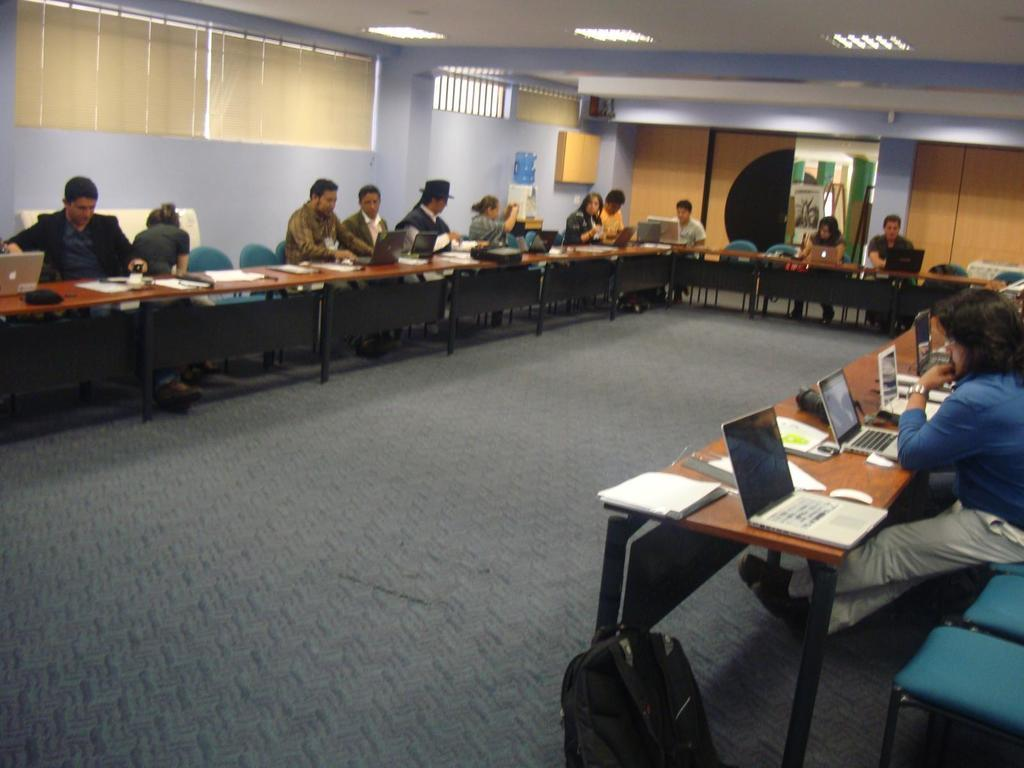How many people are in the image? There is a group of people in the image. What are the people doing in the image? The people are seated on chairs. What objects are in front of the people? There are tables in front of the people. What electronic devices can be seen in the image? There are laptops visible in the image. What type of reading material is present in the image? There are books in the image. What type of cloud can be seen in the image? There are no clouds visible in the image. 